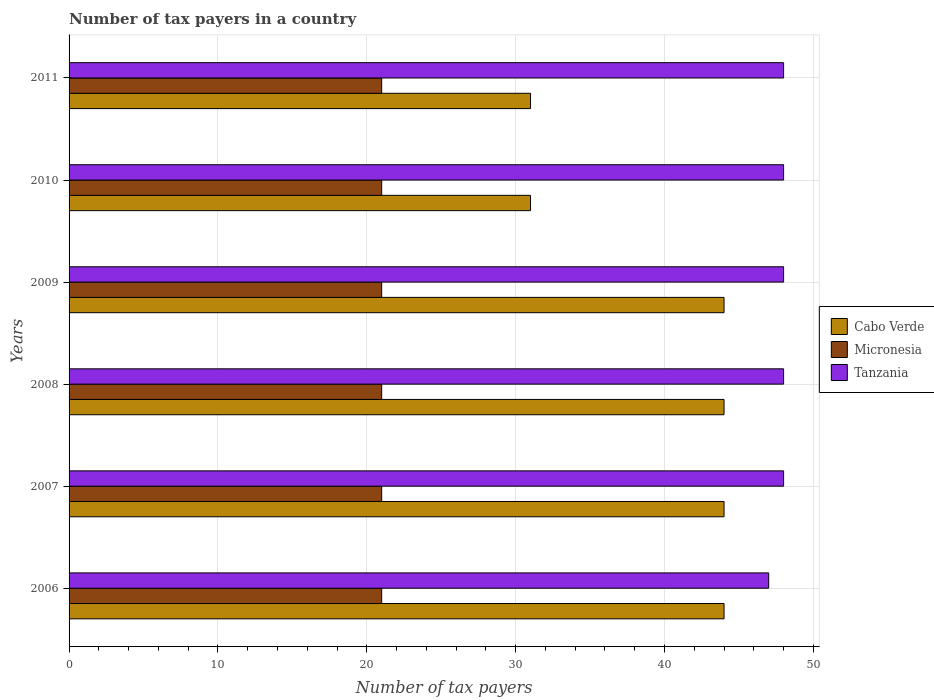How many different coloured bars are there?
Your response must be concise. 3. How many groups of bars are there?
Provide a short and direct response. 6. Are the number of bars on each tick of the Y-axis equal?
Offer a terse response. Yes. How many bars are there on the 3rd tick from the top?
Make the answer very short. 3. What is the number of tax payers in in Micronesia in 2006?
Keep it short and to the point. 21. Across all years, what is the maximum number of tax payers in in Cabo Verde?
Your answer should be compact. 44. Across all years, what is the minimum number of tax payers in in Micronesia?
Ensure brevity in your answer.  21. In which year was the number of tax payers in in Cabo Verde maximum?
Provide a succinct answer. 2006. In which year was the number of tax payers in in Tanzania minimum?
Offer a terse response. 2006. What is the total number of tax payers in in Micronesia in the graph?
Your response must be concise. 126. What is the difference between the number of tax payers in in Tanzania in 2009 and that in 2011?
Make the answer very short. 0. What is the difference between the number of tax payers in in Micronesia in 2006 and the number of tax payers in in Cabo Verde in 2007?
Your response must be concise. -23. In the year 2007, what is the difference between the number of tax payers in in Cabo Verde and number of tax payers in in Micronesia?
Offer a terse response. 23. In how many years, is the number of tax payers in in Micronesia greater than 6 ?
Offer a terse response. 6. Is the difference between the number of tax payers in in Cabo Verde in 2007 and 2011 greater than the difference between the number of tax payers in in Micronesia in 2007 and 2011?
Give a very brief answer. Yes. What is the difference between the highest and the lowest number of tax payers in in Tanzania?
Provide a short and direct response. 1. What does the 3rd bar from the top in 2011 represents?
Make the answer very short. Cabo Verde. What does the 1st bar from the bottom in 2011 represents?
Offer a terse response. Cabo Verde. How many bars are there?
Your response must be concise. 18. Are all the bars in the graph horizontal?
Your answer should be compact. Yes. How many years are there in the graph?
Your answer should be very brief. 6. Are the values on the major ticks of X-axis written in scientific E-notation?
Your response must be concise. No. Does the graph contain any zero values?
Offer a very short reply. No. Does the graph contain grids?
Provide a succinct answer. Yes. Where does the legend appear in the graph?
Your answer should be compact. Center right. How many legend labels are there?
Your answer should be very brief. 3. How are the legend labels stacked?
Provide a short and direct response. Vertical. What is the title of the graph?
Offer a very short reply. Number of tax payers in a country. What is the label or title of the X-axis?
Your answer should be compact. Number of tax payers. What is the Number of tax payers in Cabo Verde in 2007?
Keep it short and to the point. 44. What is the Number of tax payers of Micronesia in 2007?
Ensure brevity in your answer.  21. What is the Number of tax payers of Micronesia in 2008?
Ensure brevity in your answer.  21. What is the Number of tax payers in Tanzania in 2008?
Ensure brevity in your answer.  48. What is the Number of tax payers of Cabo Verde in 2009?
Provide a short and direct response. 44. What is the Number of tax payers of Tanzania in 2009?
Ensure brevity in your answer.  48. What is the Number of tax payers in Cabo Verde in 2010?
Make the answer very short. 31. What is the Number of tax payers of Tanzania in 2011?
Give a very brief answer. 48. Across all years, what is the maximum Number of tax payers in Micronesia?
Offer a terse response. 21. Across all years, what is the maximum Number of tax payers in Tanzania?
Make the answer very short. 48. Across all years, what is the minimum Number of tax payers of Cabo Verde?
Ensure brevity in your answer.  31. Across all years, what is the minimum Number of tax payers in Micronesia?
Provide a succinct answer. 21. What is the total Number of tax payers of Cabo Verde in the graph?
Offer a very short reply. 238. What is the total Number of tax payers of Micronesia in the graph?
Make the answer very short. 126. What is the total Number of tax payers of Tanzania in the graph?
Keep it short and to the point. 287. What is the difference between the Number of tax payers in Cabo Verde in 2006 and that in 2007?
Provide a succinct answer. 0. What is the difference between the Number of tax payers of Micronesia in 2006 and that in 2007?
Give a very brief answer. 0. What is the difference between the Number of tax payers of Tanzania in 2006 and that in 2007?
Your answer should be compact. -1. What is the difference between the Number of tax payers of Tanzania in 2006 and that in 2008?
Provide a short and direct response. -1. What is the difference between the Number of tax payers of Cabo Verde in 2006 and that in 2009?
Offer a terse response. 0. What is the difference between the Number of tax payers of Micronesia in 2006 and that in 2009?
Make the answer very short. 0. What is the difference between the Number of tax payers in Tanzania in 2006 and that in 2009?
Offer a terse response. -1. What is the difference between the Number of tax payers in Cabo Verde in 2006 and that in 2010?
Provide a succinct answer. 13. What is the difference between the Number of tax payers of Tanzania in 2006 and that in 2010?
Offer a very short reply. -1. What is the difference between the Number of tax payers of Micronesia in 2006 and that in 2011?
Offer a very short reply. 0. What is the difference between the Number of tax payers in Micronesia in 2007 and that in 2008?
Your response must be concise. 0. What is the difference between the Number of tax payers of Tanzania in 2007 and that in 2008?
Make the answer very short. 0. What is the difference between the Number of tax payers of Cabo Verde in 2007 and that in 2009?
Keep it short and to the point. 0. What is the difference between the Number of tax payers of Cabo Verde in 2007 and that in 2010?
Make the answer very short. 13. What is the difference between the Number of tax payers in Micronesia in 2007 and that in 2010?
Offer a very short reply. 0. What is the difference between the Number of tax payers in Cabo Verde in 2008 and that in 2009?
Provide a short and direct response. 0. What is the difference between the Number of tax payers of Micronesia in 2008 and that in 2009?
Your answer should be very brief. 0. What is the difference between the Number of tax payers of Cabo Verde in 2008 and that in 2010?
Keep it short and to the point. 13. What is the difference between the Number of tax payers in Cabo Verde in 2008 and that in 2011?
Ensure brevity in your answer.  13. What is the difference between the Number of tax payers of Micronesia in 2009 and that in 2011?
Offer a very short reply. 0. What is the difference between the Number of tax payers in Micronesia in 2010 and that in 2011?
Keep it short and to the point. 0. What is the difference between the Number of tax payers in Cabo Verde in 2006 and the Number of tax payers in Tanzania in 2007?
Provide a short and direct response. -4. What is the difference between the Number of tax payers of Cabo Verde in 2006 and the Number of tax payers of Micronesia in 2008?
Your answer should be very brief. 23. What is the difference between the Number of tax payers of Cabo Verde in 2006 and the Number of tax payers of Tanzania in 2008?
Make the answer very short. -4. What is the difference between the Number of tax payers of Cabo Verde in 2006 and the Number of tax payers of Tanzania in 2009?
Provide a succinct answer. -4. What is the difference between the Number of tax payers of Cabo Verde in 2006 and the Number of tax payers of Micronesia in 2011?
Offer a very short reply. 23. What is the difference between the Number of tax payers in Cabo Verde in 2006 and the Number of tax payers in Tanzania in 2011?
Your answer should be compact. -4. What is the difference between the Number of tax payers of Cabo Verde in 2007 and the Number of tax payers of Micronesia in 2008?
Offer a very short reply. 23. What is the difference between the Number of tax payers in Micronesia in 2007 and the Number of tax payers in Tanzania in 2008?
Make the answer very short. -27. What is the difference between the Number of tax payers in Cabo Verde in 2007 and the Number of tax payers in Micronesia in 2010?
Offer a terse response. 23. What is the difference between the Number of tax payers of Cabo Verde in 2007 and the Number of tax payers of Tanzania in 2010?
Provide a succinct answer. -4. What is the difference between the Number of tax payers of Cabo Verde in 2007 and the Number of tax payers of Tanzania in 2011?
Ensure brevity in your answer.  -4. What is the difference between the Number of tax payers of Micronesia in 2007 and the Number of tax payers of Tanzania in 2011?
Offer a very short reply. -27. What is the difference between the Number of tax payers of Cabo Verde in 2008 and the Number of tax payers of Micronesia in 2009?
Your answer should be compact. 23. What is the difference between the Number of tax payers of Micronesia in 2008 and the Number of tax payers of Tanzania in 2009?
Make the answer very short. -27. What is the difference between the Number of tax payers of Cabo Verde in 2008 and the Number of tax payers of Tanzania in 2010?
Provide a short and direct response. -4. What is the difference between the Number of tax payers in Cabo Verde in 2008 and the Number of tax payers in Micronesia in 2011?
Offer a terse response. 23. What is the difference between the Number of tax payers of Micronesia in 2008 and the Number of tax payers of Tanzania in 2011?
Provide a short and direct response. -27. What is the difference between the Number of tax payers in Cabo Verde in 2009 and the Number of tax payers in Tanzania in 2010?
Keep it short and to the point. -4. What is the difference between the Number of tax payers in Micronesia in 2009 and the Number of tax payers in Tanzania in 2010?
Your answer should be very brief. -27. What is the difference between the Number of tax payers of Cabo Verde in 2009 and the Number of tax payers of Micronesia in 2011?
Make the answer very short. 23. What is the difference between the Number of tax payers of Cabo Verde in 2009 and the Number of tax payers of Tanzania in 2011?
Make the answer very short. -4. What is the difference between the Number of tax payers of Micronesia in 2009 and the Number of tax payers of Tanzania in 2011?
Your response must be concise. -27. What is the difference between the Number of tax payers in Cabo Verde in 2010 and the Number of tax payers in Micronesia in 2011?
Ensure brevity in your answer.  10. What is the difference between the Number of tax payers of Cabo Verde in 2010 and the Number of tax payers of Tanzania in 2011?
Ensure brevity in your answer.  -17. What is the average Number of tax payers in Cabo Verde per year?
Offer a very short reply. 39.67. What is the average Number of tax payers in Micronesia per year?
Provide a short and direct response. 21. What is the average Number of tax payers of Tanzania per year?
Give a very brief answer. 47.83. In the year 2006, what is the difference between the Number of tax payers in Cabo Verde and Number of tax payers in Tanzania?
Keep it short and to the point. -3. In the year 2007, what is the difference between the Number of tax payers in Cabo Verde and Number of tax payers in Tanzania?
Give a very brief answer. -4. In the year 2007, what is the difference between the Number of tax payers of Micronesia and Number of tax payers of Tanzania?
Give a very brief answer. -27. In the year 2008, what is the difference between the Number of tax payers in Cabo Verde and Number of tax payers in Micronesia?
Offer a terse response. 23. In the year 2008, what is the difference between the Number of tax payers in Cabo Verde and Number of tax payers in Tanzania?
Ensure brevity in your answer.  -4. In the year 2009, what is the difference between the Number of tax payers of Cabo Verde and Number of tax payers of Micronesia?
Offer a very short reply. 23. In the year 2009, what is the difference between the Number of tax payers in Micronesia and Number of tax payers in Tanzania?
Your answer should be compact. -27. In the year 2010, what is the difference between the Number of tax payers of Cabo Verde and Number of tax payers of Micronesia?
Provide a short and direct response. 10. In the year 2011, what is the difference between the Number of tax payers in Cabo Verde and Number of tax payers in Micronesia?
Offer a very short reply. 10. In the year 2011, what is the difference between the Number of tax payers in Micronesia and Number of tax payers in Tanzania?
Your answer should be very brief. -27. What is the ratio of the Number of tax payers in Cabo Verde in 2006 to that in 2007?
Your answer should be very brief. 1. What is the ratio of the Number of tax payers of Tanzania in 2006 to that in 2007?
Offer a very short reply. 0.98. What is the ratio of the Number of tax payers of Cabo Verde in 2006 to that in 2008?
Keep it short and to the point. 1. What is the ratio of the Number of tax payers in Tanzania in 2006 to that in 2008?
Make the answer very short. 0.98. What is the ratio of the Number of tax payers of Micronesia in 2006 to that in 2009?
Offer a terse response. 1. What is the ratio of the Number of tax payers in Tanzania in 2006 to that in 2009?
Offer a terse response. 0.98. What is the ratio of the Number of tax payers in Cabo Verde in 2006 to that in 2010?
Make the answer very short. 1.42. What is the ratio of the Number of tax payers in Tanzania in 2006 to that in 2010?
Make the answer very short. 0.98. What is the ratio of the Number of tax payers in Cabo Verde in 2006 to that in 2011?
Your response must be concise. 1.42. What is the ratio of the Number of tax payers of Tanzania in 2006 to that in 2011?
Provide a short and direct response. 0.98. What is the ratio of the Number of tax payers in Cabo Verde in 2007 to that in 2008?
Your answer should be compact. 1. What is the ratio of the Number of tax payers in Tanzania in 2007 to that in 2008?
Provide a short and direct response. 1. What is the ratio of the Number of tax payers of Cabo Verde in 2007 to that in 2009?
Offer a terse response. 1. What is the ratio of the Number of tax payers of Micronesia in 2007 to that in 2009?
Make the answer very short. 1. What is the ratio of the Number of tax payers in Tanzania in 2007 to that in 2009?
Your response must be concise. 1. What is the ratio of the Number of tax payers of Cabo Verde in 2007 to that in 2010?
Give a very brief answer. 1.42. What is the ratio of the Number of tax payers in Micronesia in 2007 to that in 2010?
Offer a terse response. 1. What is the ratio of the Number of tax payers in Tanzania in 2007 to that in 2010?
Give a very brief answer. 1. What is the ratio of the Number of tax payers in Cabo Verde in 2007 to that in 2011?
Your answer should be compact. 1.42. What is the ratio of the Number of tax payers of Tanzania in 2007 to that in 2011?
Ensure brevity in your answer.  1. What is the ratio of the Number of tax payers in Cabo Verde in 2008 to that in 2009?
Provide a short and direct response. 1. What is the ratio of the Number of tax payers in Tanzania in 2008 to that in 2009?
Your answer should be compact. 1. What is the ratio of the Number of tax payers in Cabo Verde in 2008 to that in 2010?
Give a very brief answer. 1.42. What is the ratio of the Number of tax payers of Micronesia in 2008 to that in 2010?
Keep it short and to the point. 1. What is the ratio of the Number of tax payers of Cabo Verde in 2008 to that in 2011?
Keep it short and to the point. 1.42. What is the ratio of the Number of tax payers of Micronesia in 2008 to that in 2011?
Ensure brevity in your answer.  1. What is the ratio of the Number of tax payers of Cabo Verde in 2009 to that in 2010?
Give a very brief answer. 1.42. What is the ratio of the Number of tax payers of Cabo Verde in 2009 to that in 2011?
Offer a terse response. 1.42. What is the ratio of the Number of tax payers in Tanzania in 2009 to that in 2011?
Provide a succinct answer. 1. What is the ratio of the Number of tax payers in Micronesia in 2010 to that in 2011?
Your answer should be very brief. 1. What is the difference between the highest and the second highest Number of tax payers in Micronesia?
Ensure brevity in your answer.  0. What is the difference between the highest and the lowest Number of tax payers of Tanzania?
Your answer should be compact. 1. 